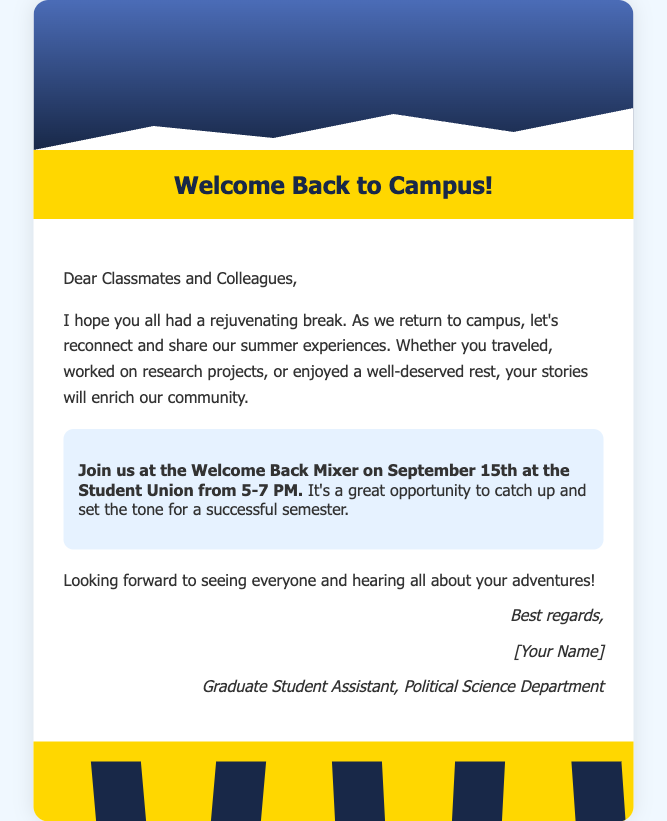What is the title of the document? The title of the document, as indicated in the header, is "Welcome Back to Campus!".
Answer: Welcome Back to Campus! When is the Welcome Back Mixer scheduled? The date and time for the Welcome Back Mixer are specified in the invitation section of the document.
Answer: September 15th at 5-7 PM Where will the Welcome Back Mixer take place? The location of the Welcome Back Mixer is mentioned in the invitation section.
Answer: Student Union Who signed the greeting card? The signature section reveals who authored the document.
Answer: [Your Name] What color is used for the header of the card? The background color of the header can be found in the style definitions.
Answer: Yellow What main activity is encouraged in this greeting card? The document encourages reconnecting and sharing summer experiences among classmates.
Answer: Reconnect and share experiences How many silhouettes are featured at the bottom of the card? The total number of silhouettes is specified in the silhouettes section.
Answer: Five What type of event is the Welcome Back Mixer? The nature of the event is inferred from the context surrounding the invitation section.
Answer: Mixer 